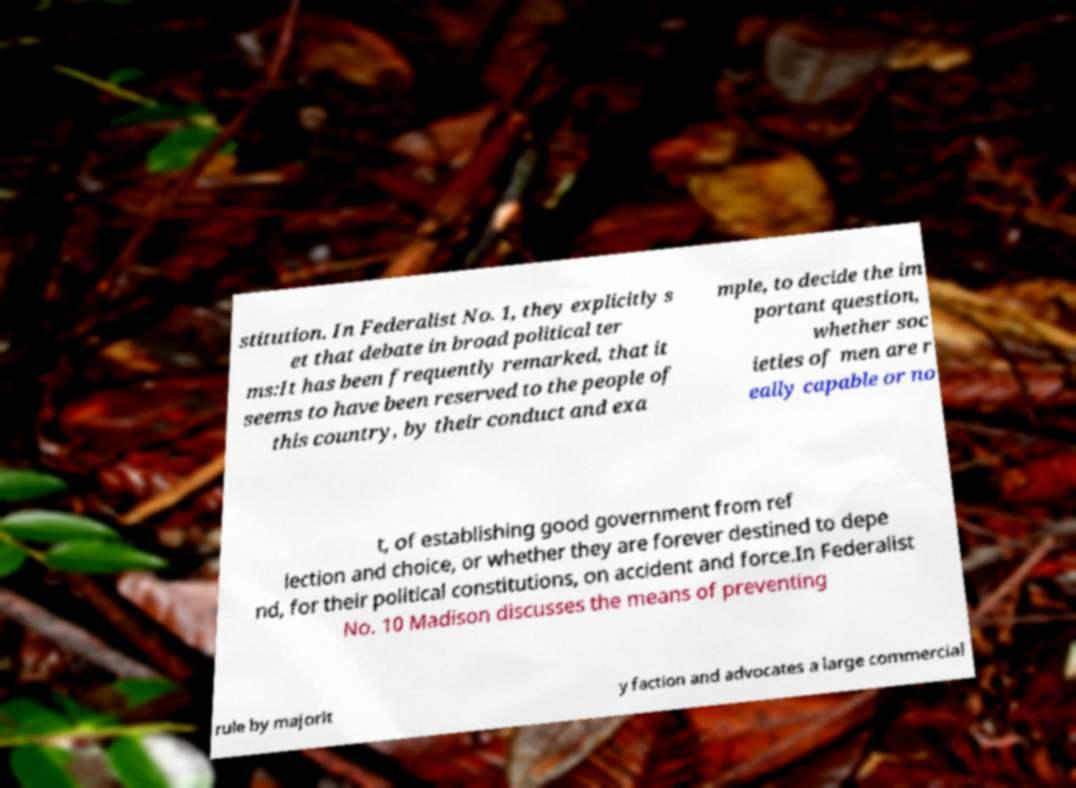Please read and relay the text visible in this image. What does it say? stitution. In Federalist No. 1, they explicitly s et that debate in broad political ter ms:It has been frequently remarked, that it seems to have been reserved to the people of this country, by their conduct and exa mple, to decide the im portant question, whether soc ieties of men are r eally capable or no t, of establishing good government from ref lection and choice, or whether they are forever destined to depe nd, for their political constitutions, on accident and force.In Federalist No. 10 Madison discusses the means of preventing rule by majorit y faction and advocates a large commercial 